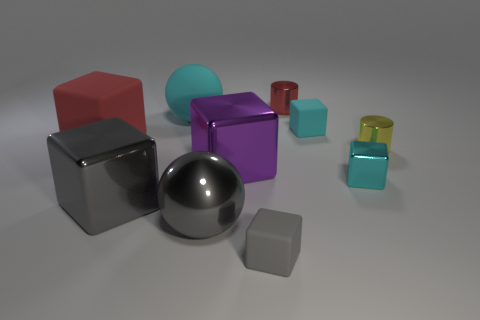There is a gray ball that is made of the same material as the small yellow object; what is its size?
Your response must be concise. Large. Are there any tiny metal things in front of the small cyan rubber block?
Your response must be concise. Yes. What is the size of the gray rubber object that is the same shape as the large red object?
Your response must be concise. Small. Does the large metallic sphere have the same color as the small metallic cylinder behind the large red rubber thing?
Offer a terse response. No. Is the color of the large rubber sphere the same as the small metallic cube?
Offer a very short reply. Yes. Is the number of big red cubes less than the number of blue objects?
Offer a terse response. No. How many other objects are there of the same color as the matte sphere?
Your answer should be compact. 2. What number of yellow metal cylinders are there?
Offer a very short reply. 1. Is the number of cylinders in front of the tiny gray rubber cube less than the number of red rubber spheres?
Your response must be concise. No. Do the red object on the right side of the small gray cube and the purple object have the same material?
Your answer should be compact. Yes. 